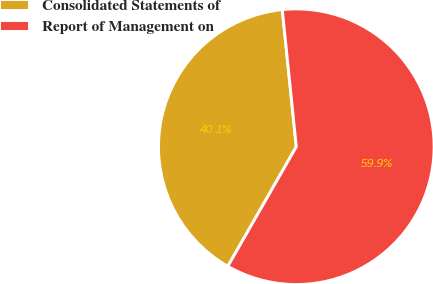<chart> <loc_0><loc_0><loc_500><loc_500><pie_chart><fcel>Consolidated Statements of<fcel>Report of Management on<nl><fcel>40.1%<fcel>59.9%<nl></chart> 